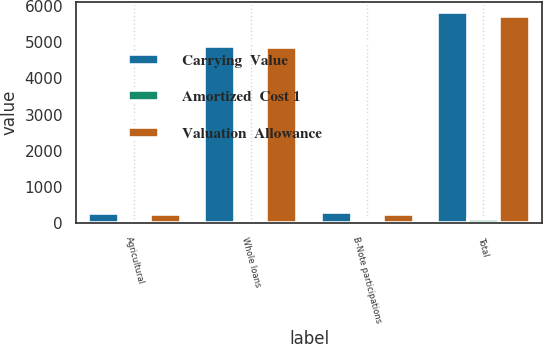Convert chart. <chart><loc_0><loc_0><loc_500><loc_500><stacked_bar_chart><ecel><fcel>Agricultural<fcel>Whole loans<fcel>B-Note participations<fcel>Total<nl><fcel>Carrying  Value<fcel>268<fcel>4892<fcel>296<fcel>5830<nl><fcel>Amortized  Cost 1<fcel>19<fcel>17<fcel>66<fcel>102<nl><fcel>Valuation  Allowance<fcel>249<fcel>4875<fcel>230<fcel>5728<nl></chart> 